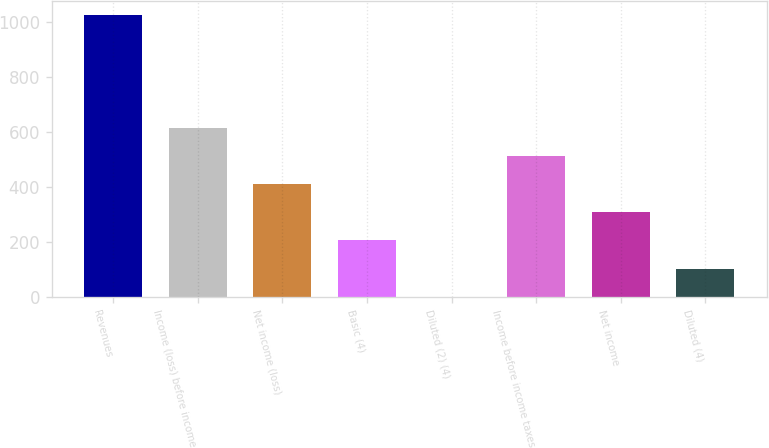Convert chart. <chart><loc_0><loc_0><loc_500><loc_500><bar_chart><fcel>Revenues<fcel>Income (loss) before income<fcel>Net income (loss)<fcel>Basic (4)<fcel>Diluted (2) (4)<fcel>Income before income taxes<fcel>Net income<fcel>Diluted (4)<nl><fcel>1025<fcel>615.48<fcel>410.72<fcel>205.96<fcel>1.2<fcel>513.1<fcel>308.34<fcel>103.58<nl></chart> 